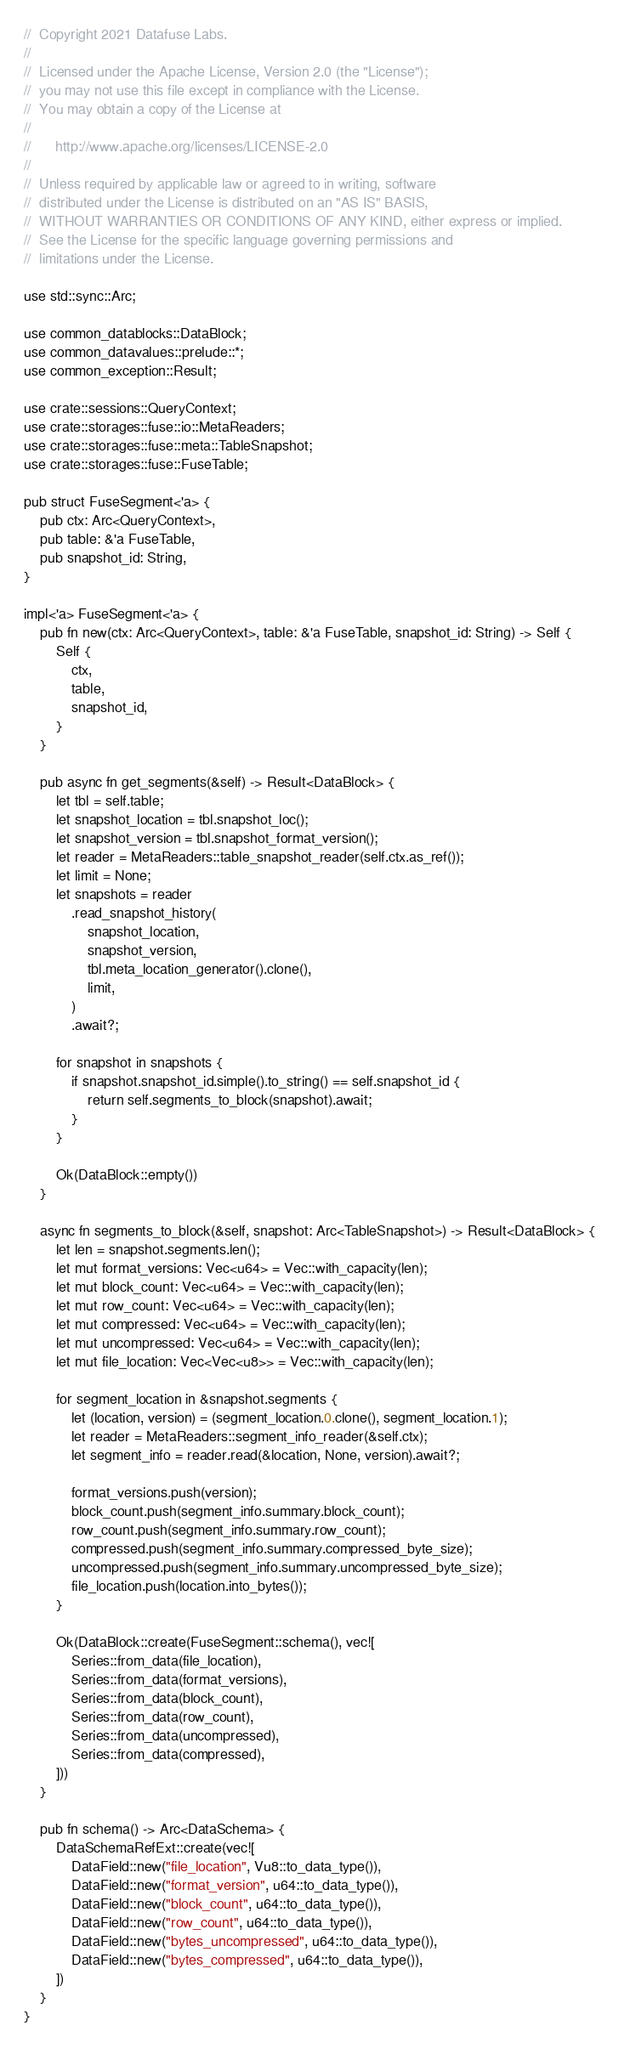Convert code to text. <code><loc_0><loc_0><loc_500><loc_500><_Rust_>//  Copyright 2021 Datafuse Labs.
//
//  Licensed under the Apache License, Version 2.0 (the "License");
//  you may not use this file except in compliance with the License.
//  You may obtain a copy of the License at
//
//      http://www.apache.org/licenses/LICENSE-2.0
//
//  Unless required by applicable law or agreed to in writing, software
//  distributed under the License is distributed on an "AS IS" BASIS,
//  WITHOUT WARRANTIES OR CONDITIONS OF ANY KIND, either express or implied.
//  See the License for the specific language governing permissions and
//  limitations under the License.

use std::sync::Arc;

use common_datablocks::DataBlock;
use common_datavalues::prelude::*;
use common_exception::Result;

use crate::sessions::QueryContext;
use crate::storages::fuse::io::MetaReaders;
use crate::storages::fuse::meta::TableSnapshot;
use crate::storages::fuse::FuseTable;

pub struct FuseSegment<'a> {
    pub ctx: Arc<QueryContext>,
    pub table: &'a FuseTable,
    pub snapshot_id: String,
}

impl<'a> FuseSegment<'a> {
    pub fn new(ctx: Arc<QueryContext>, table: &'a FuseTable, snapshot_id: String) -> Self {
        Self {
            ctx,
            table,
            snapshot_id,
        }
    }

    pub async fn get_segments(&self) -> Result<DataBlock> {
        let tbl = self.table;
        let snapshot_location = tbl.snapshot_loc();
        let snapshot_version = tbl.snapshot_format_version();
        let reader = MetaReaders::table_snapshot_reader(self.ctx.as_ref());
        let limit = None;
        let snapshots = reader
            .read_snapshot_history(
                snapshot_location,
                snapshot_version,
                tbl.meta_location_generator().clone(),
                limit,
            )
            .await?;

        for snapshot in snapshots {
            if snapshot.snapshot_id.simple().to_string() == self.snapshot_id {
                return self.segments_to_block(snapshot).await;
            }
        }

        Ok(DataBlock::empty())
    }

    async fn segments_to_block(&self, snapshot: Arc<TableSnapshot>) -> Result<DataBlock> {
        let len = snapshot.segments.len();
        let mut format_versions: Vec<u64> = Vec::with_capacity(len);
        let mut block_count: Vec<u64> = Vec::with_capacity(len);
        let mut row_count: Vec<u64> = Vec::with_capacity(len);
        let mut compressed: Vec<u64> = Vec::with_capacity(len);
        let mut uncompressed: Vec<u64> = Vec::with_capacity(len);
        let mut file_location: Vec<Vec<u8>> = Vec::with_capacity(len);

        for segment_location in &snapshot.segments {
            let (location, version) = (segment_location.0.clone(), segment_location.1);
            let reader = MetaReaders::segment_info_reader(&self.ctx);
            let segment_info = reader.read(&location, None, version).await?;

            format_versions.push(version);
            block_count.push(segment_info.summary.block_count);
            row_count.push(segment_info.summary.row_count);
            compressed.push(segment_info.summary.compressed_byte_size);
            uncompressed.push(segment_info.summary.uncompressed_byte_size);
            file_location.push(location.into_bytes());
        }

        Ok(DataBlock::create(FuseSegment::schema(), vec![
            Series::from_data(file_location),
            Series::from_data(format_versions),
            Series::from_data(block_count),
            Series::from_data(row_count),
            Series::from_data(uncompressed),
            Series::from_data(compressed),
        ]))
    }

    pub fn schema() -> Arc<DataSchema> {
        DataSchemaRefExt::create(vec![
            DataField::new("file_location", Vu8::to_data_type()),
            DataField::new("format_version", u64::to_data_type()),
            DataField::new("block_count", u64::to_data_type()),
            DataField::new("row_count", u64::to_data_type()),
            DataField::new("bytes_uncompressed", u64::to_data_type()),
            DataField::new("bytes_compressed", u64::to_data_type()),
        ])
    }
}
</code> 